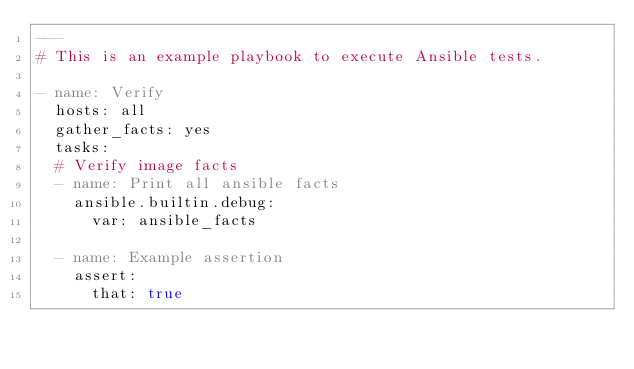<code> <loc_0><loc_0><loc_500><loc_500><_YAML_>---
# This is an example playbook to execute Ansible tests.

- name: Verify
  hosts: all
  gather_facts: yes
  tasks:
  # Verify image facts
  - name: Print all ansible facts
    ansible.builtin.debug:
      var: ansible_facts

  - name: Example assertion
    assert:
      that: true
</code> 